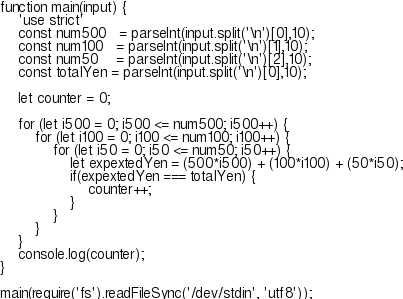<code> <loc_0><loc_0><loc_500><loc_500><_JavaScript_>function main(input) {
    'use strict'
    const num500   = parseInt(input.split('\n')[0],10);
    const num100   = parseInt(input.split('\n')[1],10);
    const num50    = parseInt(input.split('\n')[2],10);
    const totalYen = parseInt(input.split('\n')[0],10);

    let counter = 0;

    for (let i500 = 0; i500 <= num500; i500++) {
        for (let i100 = 0; i100 <= num100; i100++) {
            for (let i50 = 0; i50 <= num50; i50++) {
                let expextedYen = (500*i500) + (100*i100) + (50*i50);
                if(expextedYen === totalYen) {
                    counter++;
                }
            }
        }
    }
    console.log(counter);
}

main(require('fs').readFileSync('/dev/stdin', 'utf8'));
</code> 